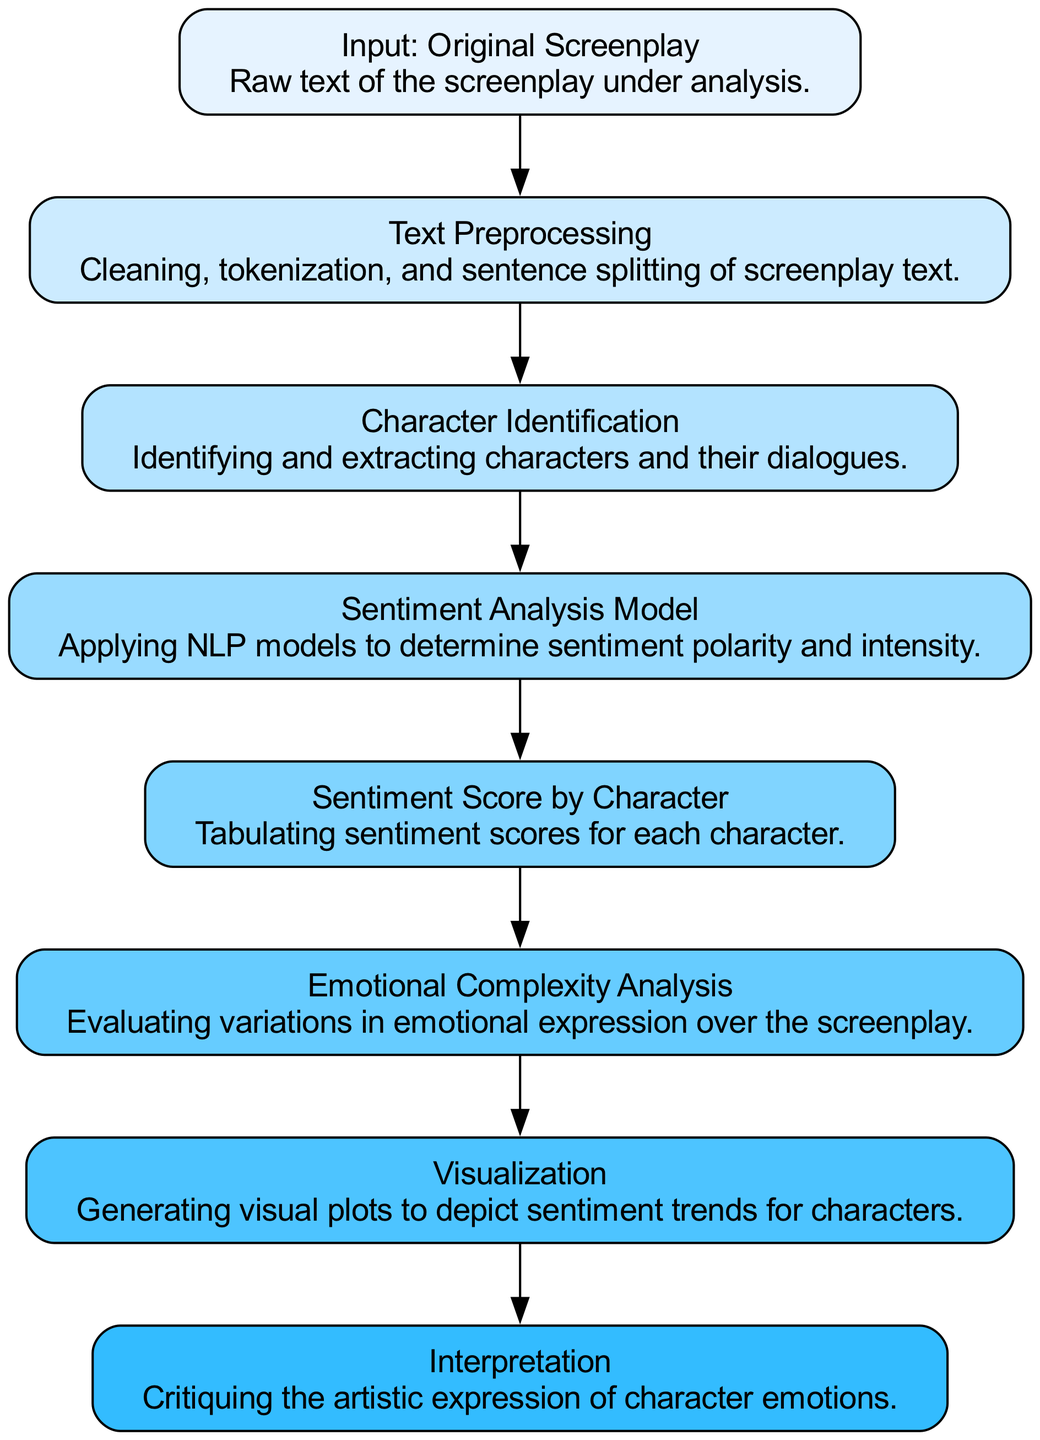What is the first step in the analysis process? The first node, labeled "Input: Original Screenplay," indicates that the analysis begins with the raw text of the screenplay.
Answer: Input: Original Screenplay How many nodes are present in the diagram? By counting the nodes listed in the data, including all processes from input to interpretation, there are a total of 8 nodes.
Answer: 8 What is the output of the "Sentiment Analysis Model"? The "Sentiment Analysis Model" node outputs sentiment polarity and intensity measurements, which determine how positive or negative the sentiments are for each character.
Answer: Sentiment polarity and intensity Which node comes after "Character Identification"? The node that comes after "Character Identification" in the flow of the diagram is the "Sentiment Analysis Model," where the identified characters' dialogues are analyzed further for sentiment.
Answer: Sentiment Analysis Model What is the final step indicated in this diagram? The last node, "Interpretation," signifies the final step of the process where the artistic expression of character emotions is critiqued.
Answer: Interpretation How does the "Sentiment Score by Character" relate to the "Emotional Complexity Analysis"? The "Sentiment Score by Character" node provides the scores that are then used in the "Emotional Complexity Analysis" node to evaluate variations in emotional expression across the screenplay.
Answer: Provides scores for evaluation What is the purpose of the "Visualization" node? The "Visualization" node is used to generate visual plots depicting sentiment trends for characters, making it easier to analyze and interpret emotional data visually.
Answer: Generate visual plots Which nodes are connected to the "Sentiment Analysis Model"? The "Sentiment Analysis Model" is connected to two nodes: "Character Identification" (as its input) and "Sentiment Score by Character" (as its output), indicating the flow of data from character analysis to sentiment scoring.
Answer: Character Identification and Sentiment Score by Character 